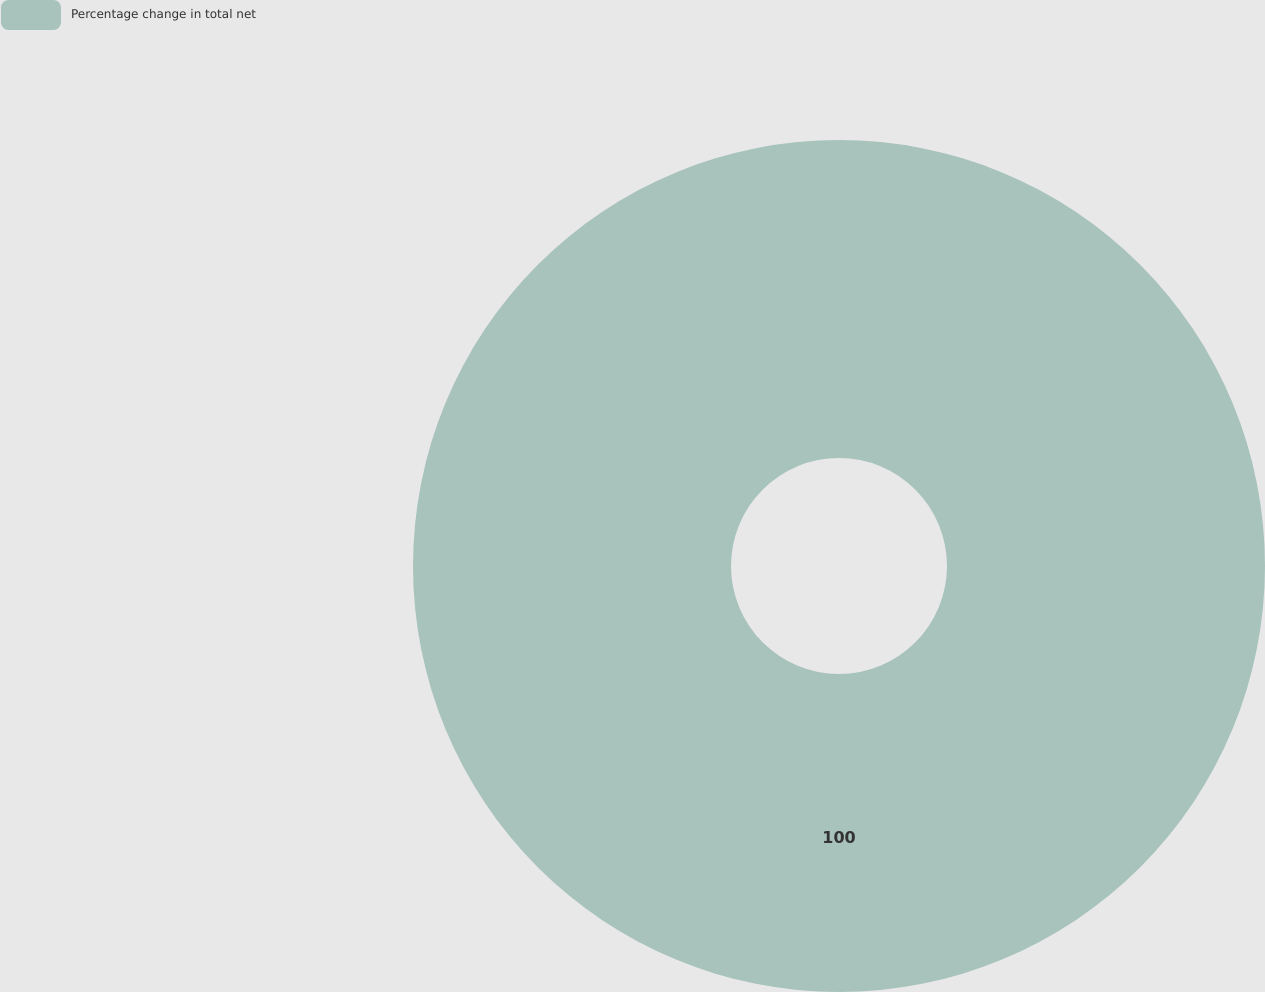Convert chart to OTSL. <chart><loc_0><loc_0><loc_500><loc_500><pie_chart><fcel>Percentage change in total net<nl><fcel>100.0%<nl></chart> 